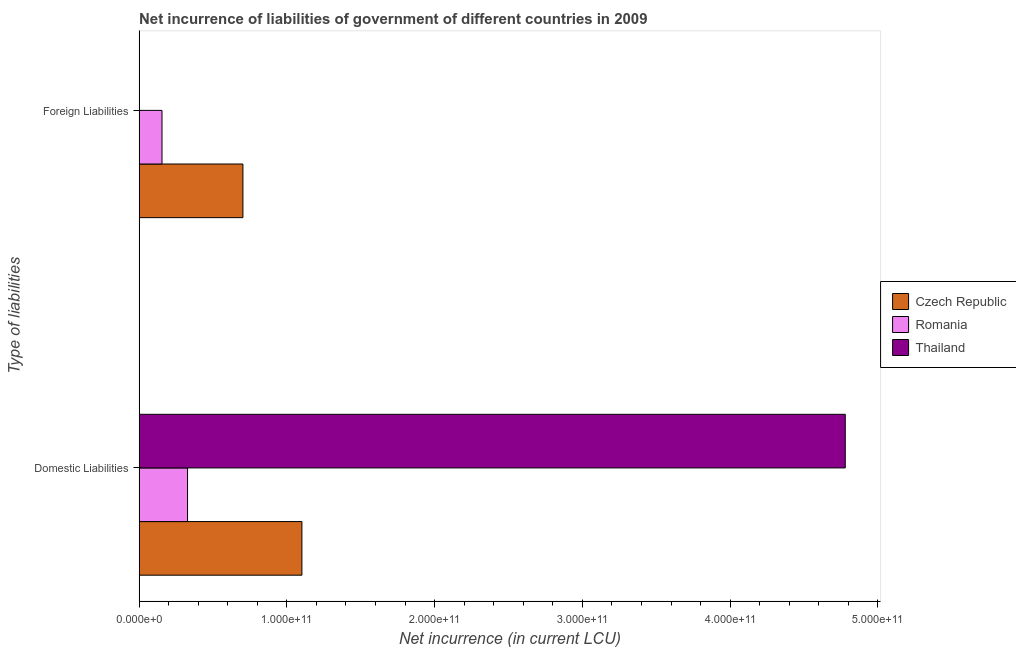Are the number of bars on each tick of the Y-axis equal?
Offer a very short reply. No. How many bars are there on the 1st tick from the top?
Your response must be concise. 2. How many bars are there on the 2nd tick from the bottom?
Offer a very short reply. 2. What is the label of the 2nd group of bars from the top?
Your answer should be compact. Domestic Liabilities. What is the net incurrence of domestic liabilities in Romania?
Ensure brevity in your answer.  3.28e+1. Across all countries, what is the maximum net incurrence of domestic liabilities?
Provide a succinct answer. 4.78e+11. Across all countries, what is the minimum net incurrence of domestic liabilities?
Provide a succinct answer. 3.28e+1. In which country was the net incurrence of foreign liabilities maximum?
Keep it short and to the point. Czech Republic. What is the total net incurrence of foreign liabilities in the graph?
Offer a very short reply. 8.58e+1. What is the difference between the net incurrence of foreign liabilities in Romania and that in Czech Republic?
Offer a very short reply. -5.48e+1. What is the difference between the net incurrence of foreign liabilities in Thailand and the net incurrence of domestic liabilities in Romania?
Ensure brevity in your answer.  -3.28e+1. What is the average net incurrence of domestic liabilities per country?
Provide a succinct answer. 2.07e+11. What is the difference between the net incurrence of domestic liabilities and net incurrence of foreign liabilities in Czech Republic?
Make the answer very short. 3.99e+1. In how many countries, is the net incurrence of foreign liabilities greater than 320000000000 LCU?
Your answer should be compact. 0. What is the ratio of the net incurrence of domestic liabilities in Czech Republic to that in Thailand?
Your response must be concise. 0.23. Is the net incurrence of foreign liabilities in Romania less than that in Czech Republic?
Your answer should be compact. Yes. How many bars are there?
Your response must be concise. 5. Are all the bars in the graph horizontal?
Ensure brevity in your answer.  Yes. How many countries are there in the graph?
Give a very brief answer. 3. What is the difference between two consecutive major ticks on the X-axis?
Ensure brevity in your answer.  1.00e+11. Does the graph contain grids?
Give a very brief answer. No. Where does the legend appear in the graph?
Keep it short and to the point. Center right. How are the legend labels stacked?
Your answer should be compact. Vertical. What is the title of the graph?
Make the answer very short. Net incurrence of liabilities of government of different countries in 2009. What is the label or title of the X-axis?
Your response must be concise. Net incurrence (in current LCU). What is the label or title of the Y-axis?
Offer a very short reply. Type of liabilities. What is the Net incurrence (in current LCU) in Czech Republic in Domestic Liabilities?
Offer a terse response. 1.10e+11. What is the Net incurrence (in current LCU) in Romania in Domestic Liabilities?
Provide a succinct answer. 3.28e+1. What is the Net incurrence (in current LCU) in Thailand in Domestic Liabilities?
Your response must be concise. 4.78e+11. What is the Net incurrence (in current LCU) in Czech Republic in Foreign Liabilities?
Keep it short and to the point. 7.03e+1. What is the Net incurrence (in current LCU) of Romania in Foreign Liabilities?
Your answer should be very brief. 1.55e+1. What is the Net incurrence (in current LCU) of Thailand in Foreign Liabilities?
Offer a terse response. 0. Across all Type of liabilities, what is the maximum Net incurrence (in current LCU) in Czech Republic?
Offer a very short reply. 1.10e+11. Across all Type of liabilities, what is the maximum Net incurrence (in current LCU) of Romania?
Provide a succinct answer. 3.28e+1. Across all Type of liabilities, what is the maximum Net incurrence (in current LCU) of Thailand?
Ensure brevity in your answer.  4.78e+11. Across all Type of liabilities, what is the minimum Net incurrence (in current LCU) of Czech Republic?
Your answer should be compact. 7.03e+1. Across all Type of liabilities, what is the minimum Net incurrence (in current LCU) of Romania?
Offer a very short reply. 1.55e+1. Across all Type of liabilities, what is the minimum Net incurrence (in current LCU) in Thailand?
Ensure brevity in your answer.  0. What is the total Net incurrence (in current LCU) of Czech Republic in the graph?
Offer a very short reply. 1.80e+11. What is the total Net incurrence (in current LCU) of Romania in the graph?
Your answer should be compact. 4.83e+1. What is the total Net incurrence (in current LCU) in Thailand in the graph?
Offer a terse response. 4.78e+11. What is the difference between the Net incurrence (in current LCU) in Czech Republic in Domestic Liabilities and that in Foreign Liabilities?
Keep it short and to the point. 3.99e+1. What is the difference between the Net incurrence (in current LCU) in Romania in Domestic Liabilities and that in Foreign Liabilities?
Your answer should be compact. 1.73e+1. What is the difference between the Net incurrence (in current LCU) in Czech Republic in Domestic Liabilities and the Net incurrence (in current LCU) in Romania in Foreign Liabilities?
Offer a terse response. 9.47e+1. What is the average Net incurrence (in current LCU) in Czech Republic per Type of liabilities?
Offer a very short reply. 9.02e+1. What is the average Net incurrence (in current LCU) in Romania per Type of liabilities?
Keep it short and to the point. 2.41e+1. What is the average Net incurrence (in current LCU) in Thailand per Type of liabilities?
Keep it short and to the point. 2.39e+11. What is the difference between the Net incurrence (in current LCU) in Czech Republic and Net incurrence (in current LCU) in Romania in Domestic Liabilities?
Ensure brevity in your answer.  7.74e+1. What is the difference between the Net incurrence (in current LCU) of Czech Republic and Net incurrence (in current LCU) of Thailand in Domestic Liabilities?
Your response must be concise. -3.68e+11. What is the difference between the Net incurrence (in current LCU) in Romania and Net incurrence (in current LCU) in Thailand in Domestic Liabilities?
Provide a short and direct response. -4.45e+11. What is the difference between the Net incurrence (in current LCU) of Czech Republic and Net incurrence (in current LCU) of Romania in Foreign Liabilities?
Your answer should be compact. 5.48e+1. What is the ratio of the Net incurrence (in current LCU) in Czech Republic in Domestic Liabilities to that in Foreign Liabilities?
Provide a succinct answer. 1.57. What is the ratio of the Net incurrence (in current LCU) of Romania in Domestic Liabilities to that in Foreign Liabilities?
Keep it short and to the point. 2.12. What is the difference between the highest and the second highest Net incurrence (in current LCU) in Czech Republic?
Offer a terse response. 3.99e+1. What is the difference between the highest and the second highest Net incurrence (in current LCU) of Romania?
Make the answer very short. 1.73e+1. What is the difference between the highest and the lowest Net incurrence (in current LCU) of Czech Republic?
Keep it short and to the point. 3.99e+1. What is the difference between the highest and the lowest Net incurrence (in current LCU) in Romania?
Provide a succinct answer. 1.73e+1. What is the difference between the highest and the lowest Net incurrence (in current LCU) in Thailand?
Keep it short and to the point. 4.78e+11. 